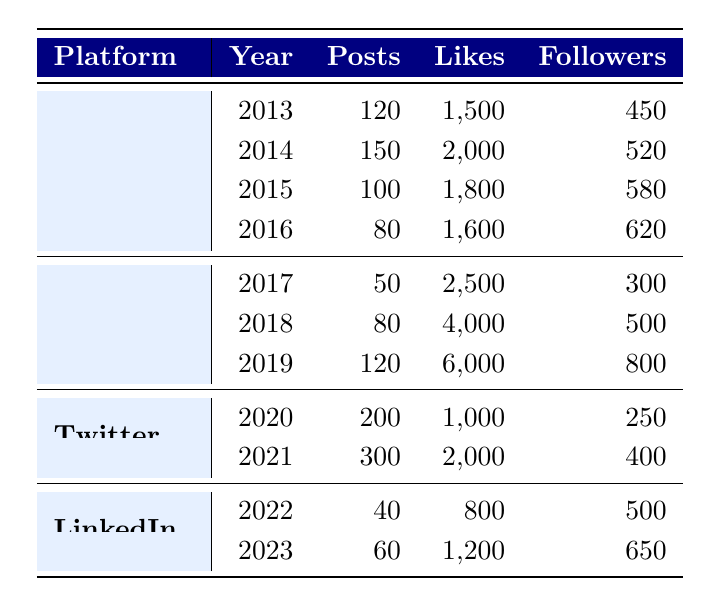What year had the highest number of posts on Facebook? In the table, the number of posts on Facebook is listed for each year. By comparing the numbers: 120 (2013), 150 (2014), 100 (2015), and 80 (2016), we see that 150 in 2014 is the highest.
Answer: 2014 How many likes did John receive on Instagram in 2019? The table indicates that in 2019, the likes received on Instagram were 6000.
Answer: 6000 What is the total number of posts made by John on Twitter over the two years? The table indicates John made 200 posts in 2020 and 300 posts in 2021. By summing these values: 200 + 300 = 500.
Answer: 500 Is it true that John had more likes on Instagram in 2019 than on Facebook in 2014? Looking at the numbers, John received 6000 likes on Instagram in 2019, while in 2014 he received 2000 likes on Facebook. Since 6000 is greater than 2000, the statement is true.
Answer: Yes What was the average number of likes received on Facebook across the years shown? The likes received on Facebook are 1500 (2013), 2000 (2014), 1800 (2015), and 1600 (2016). Summing these gives 1500 + 2000 + 1800 + 1600 = 6900. There are 4 data points, so dividing by 4 gives an average of 6900 / 4 = 1725.
Answer: 1725 What is the increase in the number of connections from LinkedIn in 2022 to 2023? In 2022, John had 500 connections, while in 2023 he had 650 connections. The increase is calculated by 650 - 500 = 150.
Answer: 150 In which year did John receive the fewest likes on LinkedIn? Reviewing the likes across the years on LinkedIn, we have 800 (2022) and 1200 (2023). The fewest likes were received in 2022 with 800 likes.
Answer: 2022 How many posts were made on Instagram from 2017 to 2019? The number of Instagram posts are as follows: 50 (2017), 80 (2018), and 120 (2019). Summing these amounts gives 50 + 80 + 120 = 250.
Answer: 250 Did John have more posts on Facebook in 2013 than he had on Twitter in 2021? The table shows 120 posts on Facebook in 2013 and 300 posts on Twitter in 2021. Since 120 is less than 300, the statement is false.
Answer: No 